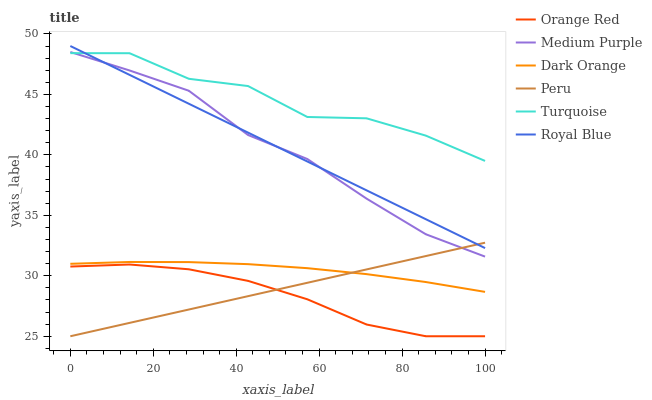Does Medium Purple have the minimum area under the curve?
Answer yes or no. No. Does Medium Purple have the maximum area under the curve?
Answer yes or no. No. Is Medium Purple the smoothest?
Answer yes or no. No. Is Medium Purple the roughest?
Answer yes or no. No. Does Medium Purple have the lowest value?
Answer yes or no. No. Does Turquoise have the highest value?
Answer yes or no. No. Is Peru less than Turquoise?
Answer yes or no. Yes. Is Turquoise greater than Peru?
Answer yes or no. Yes. Does Peru intersect Turquoise?
Answer yes or no. No. 